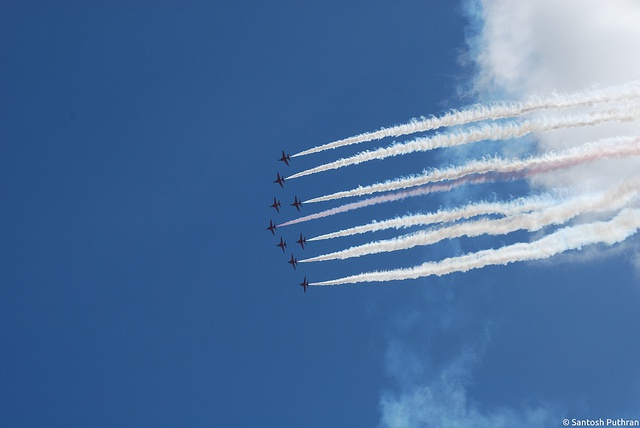Describe the objects in this image and their specific colors. I can see airplane in blue, black, navy, and darkblue tones, airplane in blue, black, and navy tones, airplane in blue, black, and navy tones, airplane in blue, black, and navy tones, and airplane in blue, navy, black, and darkblue tones in this image. 